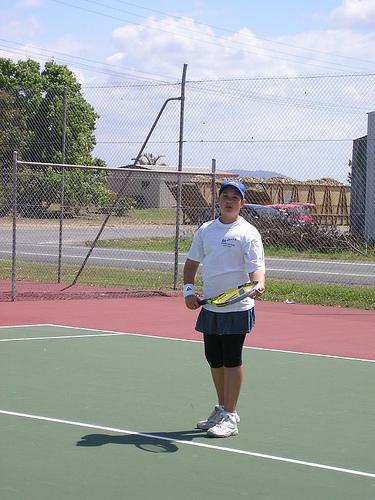What is the graphic on the man's shirt?
Answer briefly. Logo. Is this person in the middle of serving?
Short answer required. No. What is the man holding?
Keep it brief. Tennis racquet. What sport is shown?
Keep it brief. Tennis. Is the young man left handed?
Be succinct. No. What is the weather like?
Quick response, please. Sunny. What is the girl looking at?
Be succinct. Camera. 